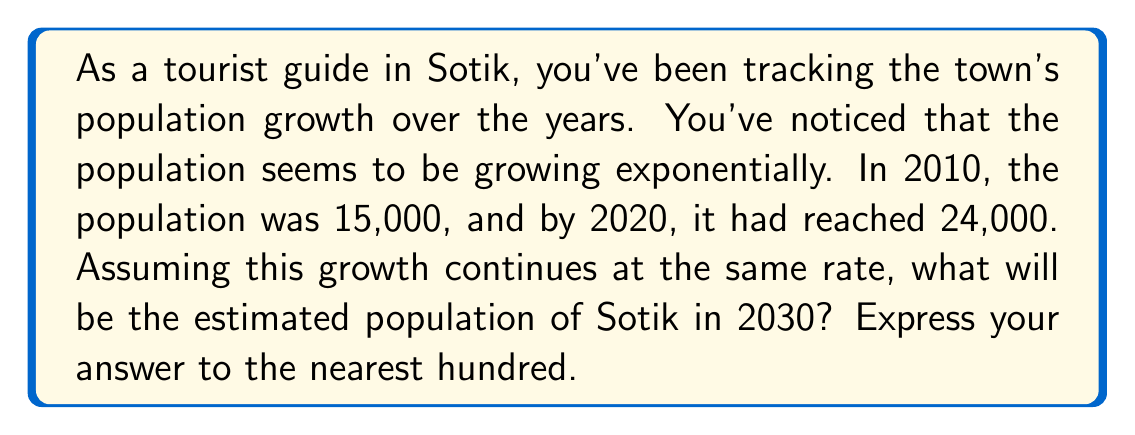Provide a solution to this math problem. To solve this problem, we'll use the exponential growth formula:

$$P(t) = P_0 \cdot e^{rt}$$

Where:
$P(t)$ is the population at time $t$
$P_0$ is the initial population
$r$ is the growth rate
$t$ is the time elapsed

We know:
$P_0 = 15,000$ (population in 2010)
$P(10) = 24,000$ (population in 2020, 10 years later)

First, let's find the growth rate $r$:

$$24,000 = 15,000 \cdot e^{10r}$$

Dividing both sides by 15,000:

$$1.6 = e^{10r}$$

Taking the natural log of both sides:

$$\ln(1.6) = 10r$$

$$r = \frac{\ln(1.6)}{10} \approx 0.0470$$

Now that we have $r$, we can predict the population in 2030 (20 years from 2010):

$$P(20) = 15,000 \cdot e^{0.0470 \cdot 20}$$

$$P(20) = 15,000 \cdot e^{0.9400}$$

$$P(20) = 15,000 \cdot 2.5600$$

$$P(20) = 38,400$$

Rounding to the nearest hundred:

$$P(20) \approx 38,400$$
Answer: 38,400 